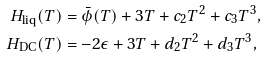Convert formula to latex. <formula><loc_0><loc_0><loc_500><loc_500>H _ { \text {liq} } ( T ) & = \bar { \phi } ( T ) + 3 T + c _ { 2 } T ^ { 2 } + c _ { 3 } T ^ { 3 } , \\ H _ { \text {DC} } ( T ) & = - 2 \epsilon + 3 T + d _ { 2 } T ^ { 2 } + d _ { 3 } T ^ { 3 } ,</formula> 